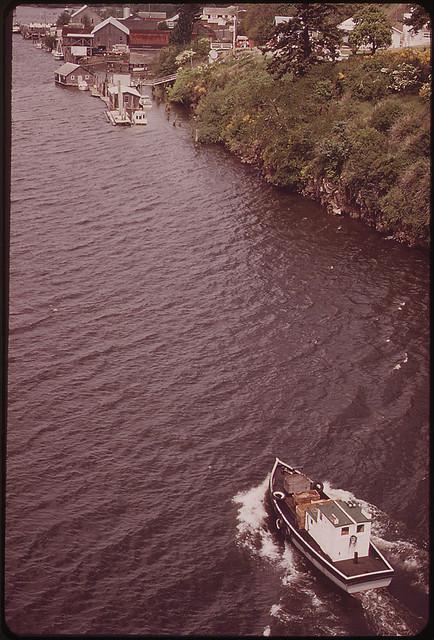Is the water clean?
Quick response, please. No. Does this look like a good spot to go fishing?
Be succinct. Yes. Is this a banana peel?
Quick response, please. No. What is on the boat?
Write a very short answer. House. How deep is water?
Keep it brief. Very deep. How many boats?
Be succinct. 1. Is the boat moving?
Give a very brief answer. Yes. Does the water seem calm?
Quick response, please. Yes. Is this an underwater scene?
Concise answer only. No. 